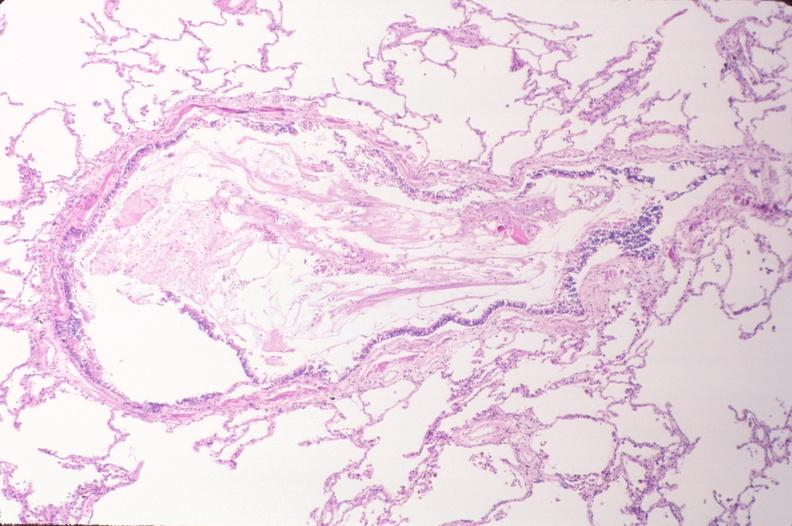s total effacement case present?
Answer the question using a single word or phrase. No 